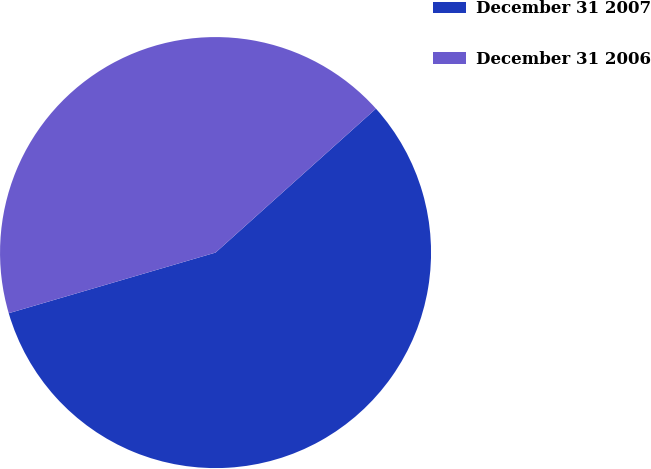<chart> <loc_0><loc_0><loc_500><loc_500><pie_chart><fcel>December 31 2007<fcel>December 31 2006<nl><fcel>57.1%<fcel>42.9%<nl></chart> 